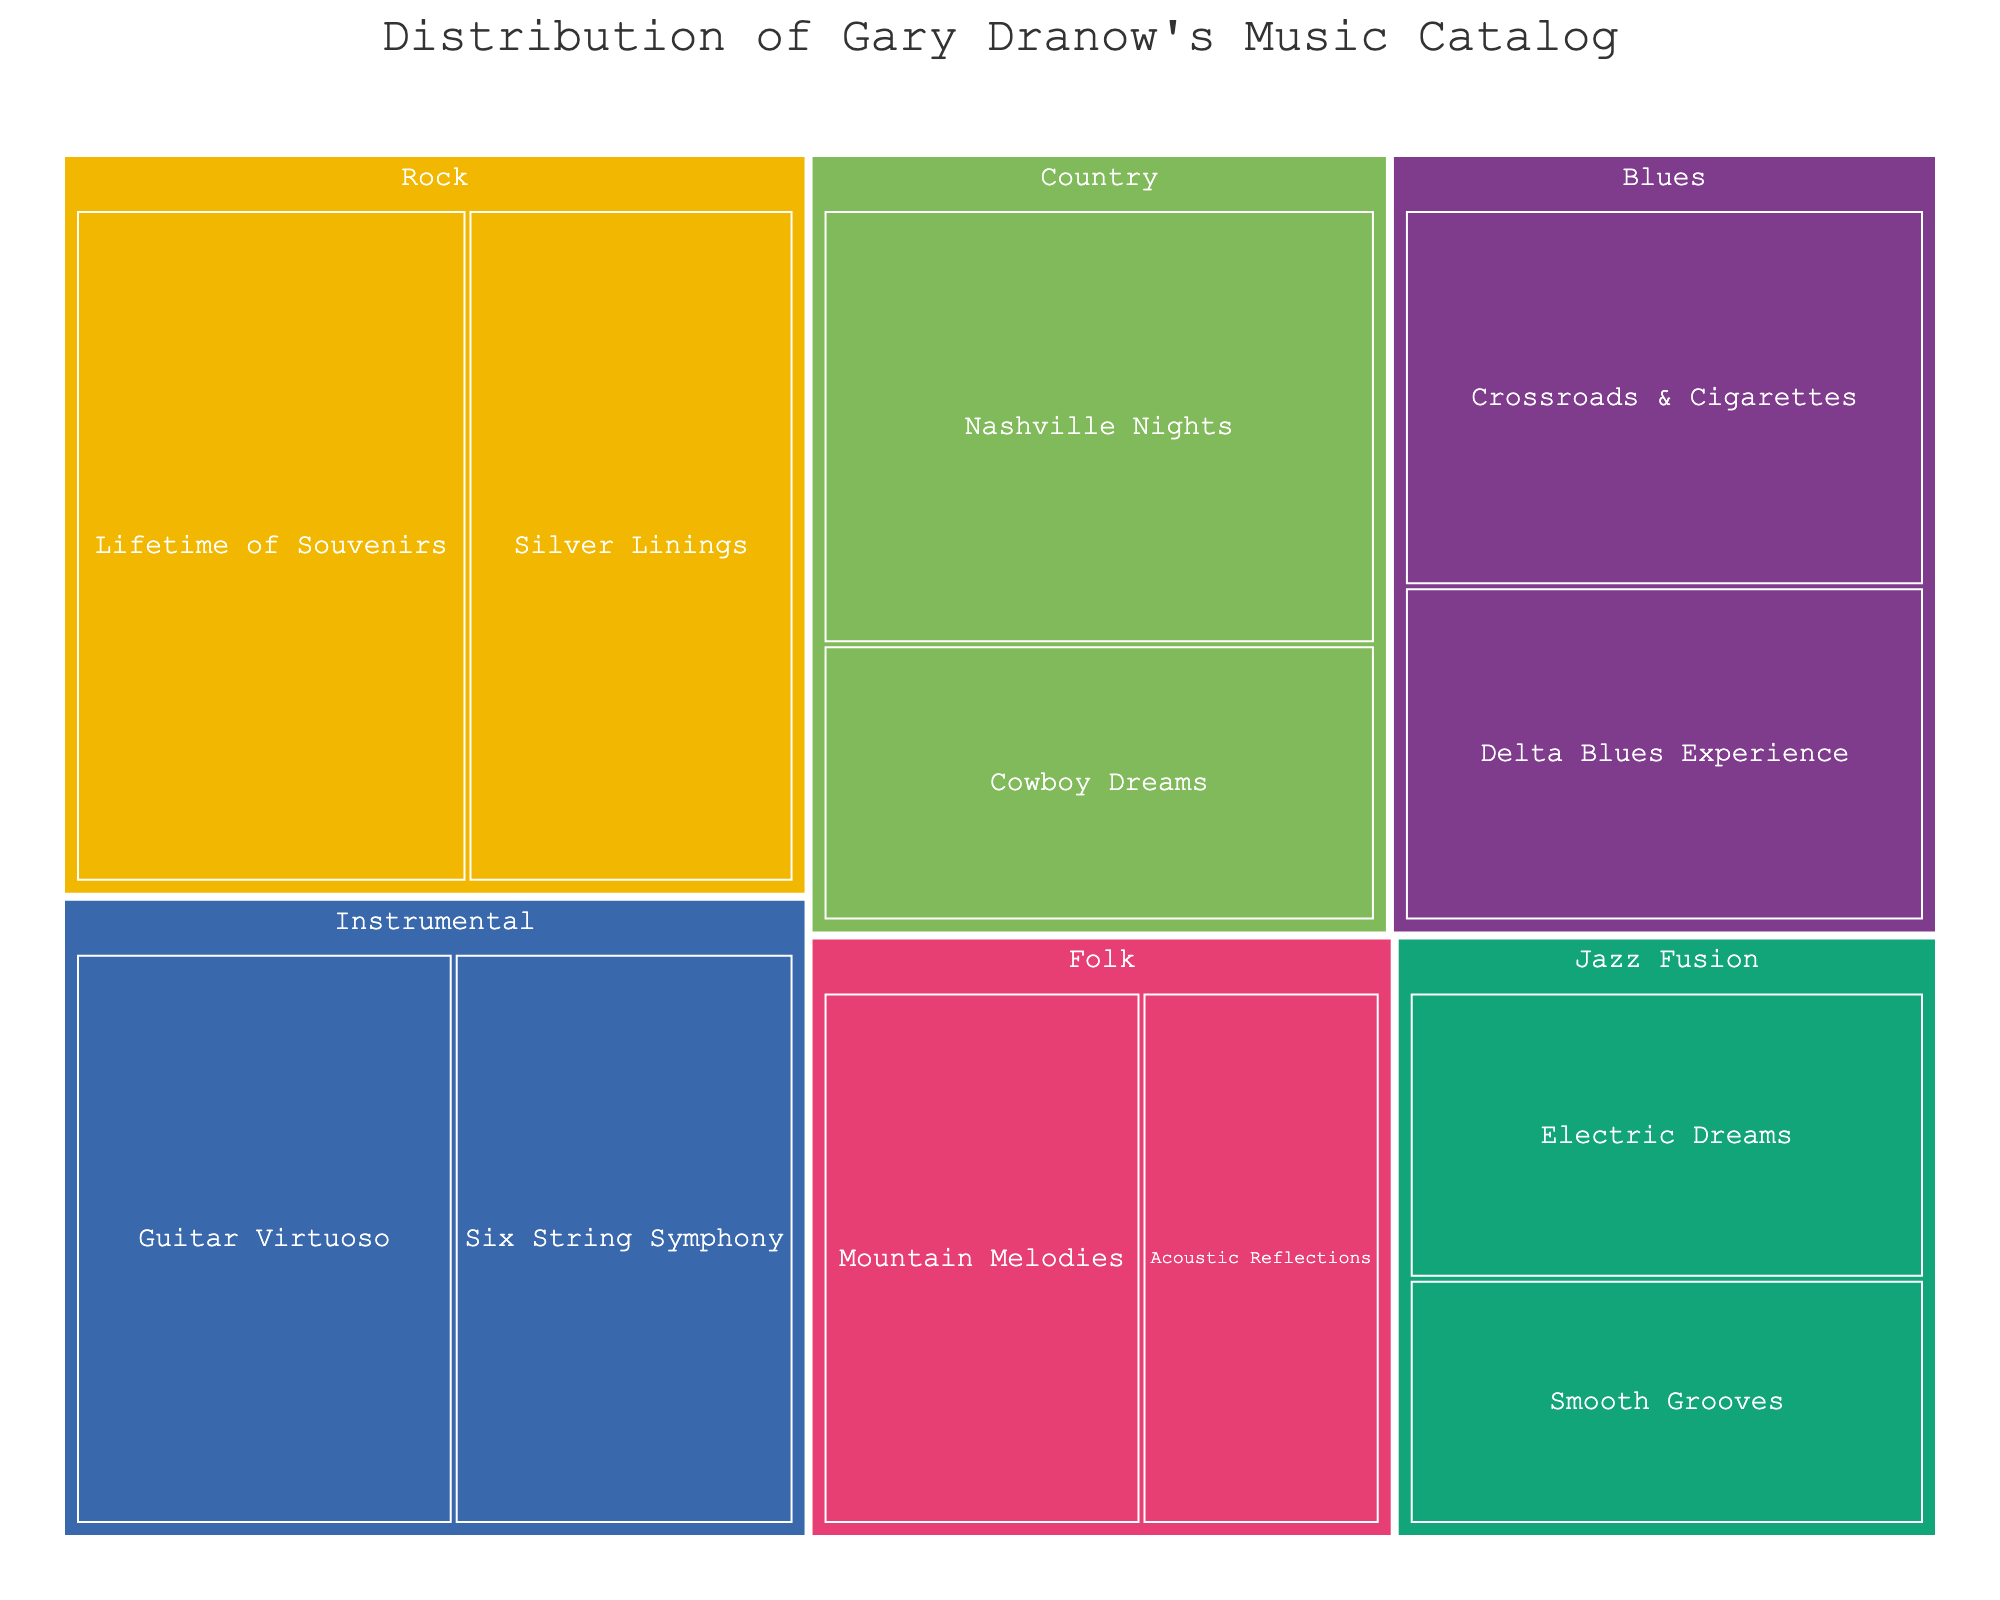What is the title of the figure? The title is typically displayed at the top of the figure, indicating the main subject or data focus
Answer: Distribution of Gary Dranow's Music Catalog Which genre has the most songs? By looking at the treemap, you can visually compare the size of the segments representing each genre
Answer: Rock How many songs are in the "Electric Dreams" album? Navigate to the "Jazz Fusion" genre segment, then find the "Electric Dreams" sub-segment to see the number of songs
Answer: 7 Which album has more songs: "Nashville Nights" or "Cowboy Dreams"? Compare the sizes of the two sub-segments under the "Country" genre. "Nashville Nights" has 11 songs, and "Cowboy Dreams" has 7 songs
Answer: Nashville Nights What is the total number of songs in the "Instrumental" genre? Add the number of songs in "Guitar Virtuoso" and "Six String Symphony" albums. 10 + 9 = 19
Answer: 19 Which genre has the smallest number of songs overall? Look for the smallest segment in the treemap, representing the fewest total songs
Answer: Folk What is the average number of songs per album in the "Blues" genre? Calculate by adding the number of songs in "Delta Blues Experience" and "Crossroads & Cigarettes," then divide by 2. (8 + 9) / 2 = 8.5
Answer: 8.5 How does the number of songs in the "Smooth Grooves" album compare to the "Acoustic Reflections" album? Check the "Jazz Fusion" and "Folk" genres to compare the sizes of "Smooth Grooves" (6 songs) and "Acoustic Reflections" (6 songs)
Answer: Equal Which "Rock" album, "Lifetime of Souvenirs" or "Silver Linings," has more songs? Both albums belong to the "Rock" genre; compare the number of songs in each sub-segment. "Lifetime of Souvenirs" has 12 songs, "Silver Linings" has 10 songs
Answer: Lifetime of Souvenirs What is the proportion of "Country" genre songs relative to the total songs in the catalog? Add the number of songs in all albums under "Country" and divide by the total number of songs in the catalog. Total "Country" songs: 11 + 7 = 18. Total songs in catalog: 12 + 10 + 8 + 9 + 11 + 7 + 6 + 8 + 7 + 6 + 10 + 9 = 103. Proportion: 18 / 103 ≈ 0.175
Answer: 0.175 